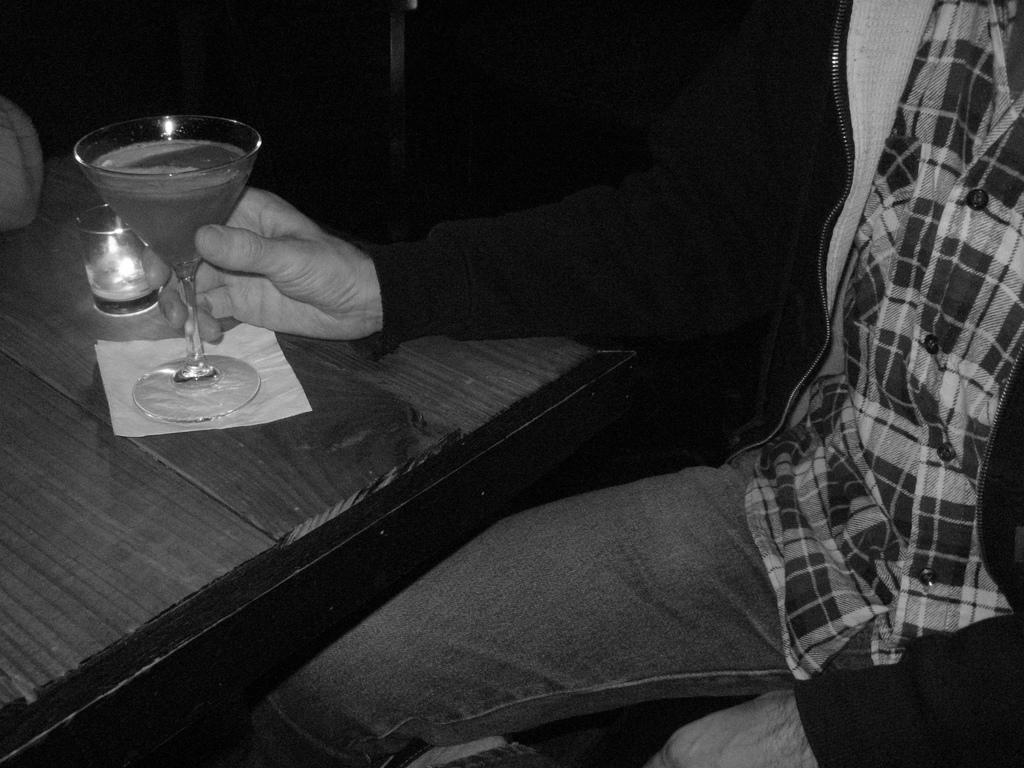Who is present in the image? There is a man in the image. What is the man holding in the image? The man is holding a glass. What object can be seen in the image that is typically used for placing objects on? There is a table in the image. What type of lace can be seen on the man's clothing in the image? There is no lace visible on the man's clothing in the image. 